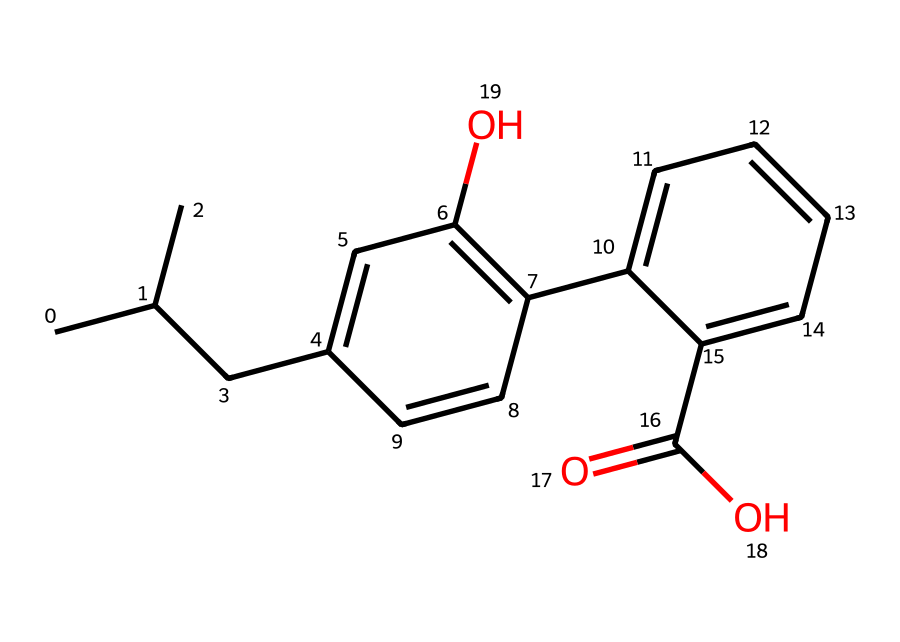what is the molecular formula of this compound? To determine the molecular formula, we count the different atoms present in the structure: there are 18 carbon (C) atoms, 17 hydrogen (H) atoms, and 3 oxygen (O) atoms. Collectively, this results in a molecular formula of C18H17O3.
Answer: C18H17O3 how many rings are present in this structure? By examining the structure, we see two distinct rings: one is a six-membered aromatic ring and the other is a five-membered ring connected through a linker. Therefore, the total number of rings is two.
Answer: 2 what functional groups are present in this compound? Analyzing the chemical structure reveals several functional groups: there is a carboxylic acid (-COOH) group and a hydroxyl (-OH) group. These groups are indicative of the compound's reactivity and properties.
Answer: carboxylic acid and hydroxyl what type of compound is this? The presence of the -COOH and -OH groups along with the aromatic rings indicates that this compound is classified as a nonsteroidal anti-inflammatory drug (NSAID). Such drugs are commonly used to reduce inflammation and pain.
Answer: NSAID how does the presence of carboxylic acid affect this compound's solubility? The carboxylic acid group introduces polarity to the molecule, allowing it to interact with polar solvents like water, which generally increases solubility. Therefore, we can infer that the carboxylic acid enhances solubility in polar solvents.
Answer: increases solubility what role does the hydroxyl group play in the biochemistry of this drug? The hydroxyl group plays a critical role in the drug's interactions with biological targets, as it can form hydrogen bonds with proteins, influencing the drug's bioavailability and activity in biological systems.
Answer: influences bioavailability which part of the molecule is responsible for its anti-inflammatory properties? The core structure containing the carboxylic acid is primarily responsible for the anti-inflammatory properties, as this moiety interacts with enzymes involved in the inflammatory process, inhibiting their action.
Answer: carboxylic acid 